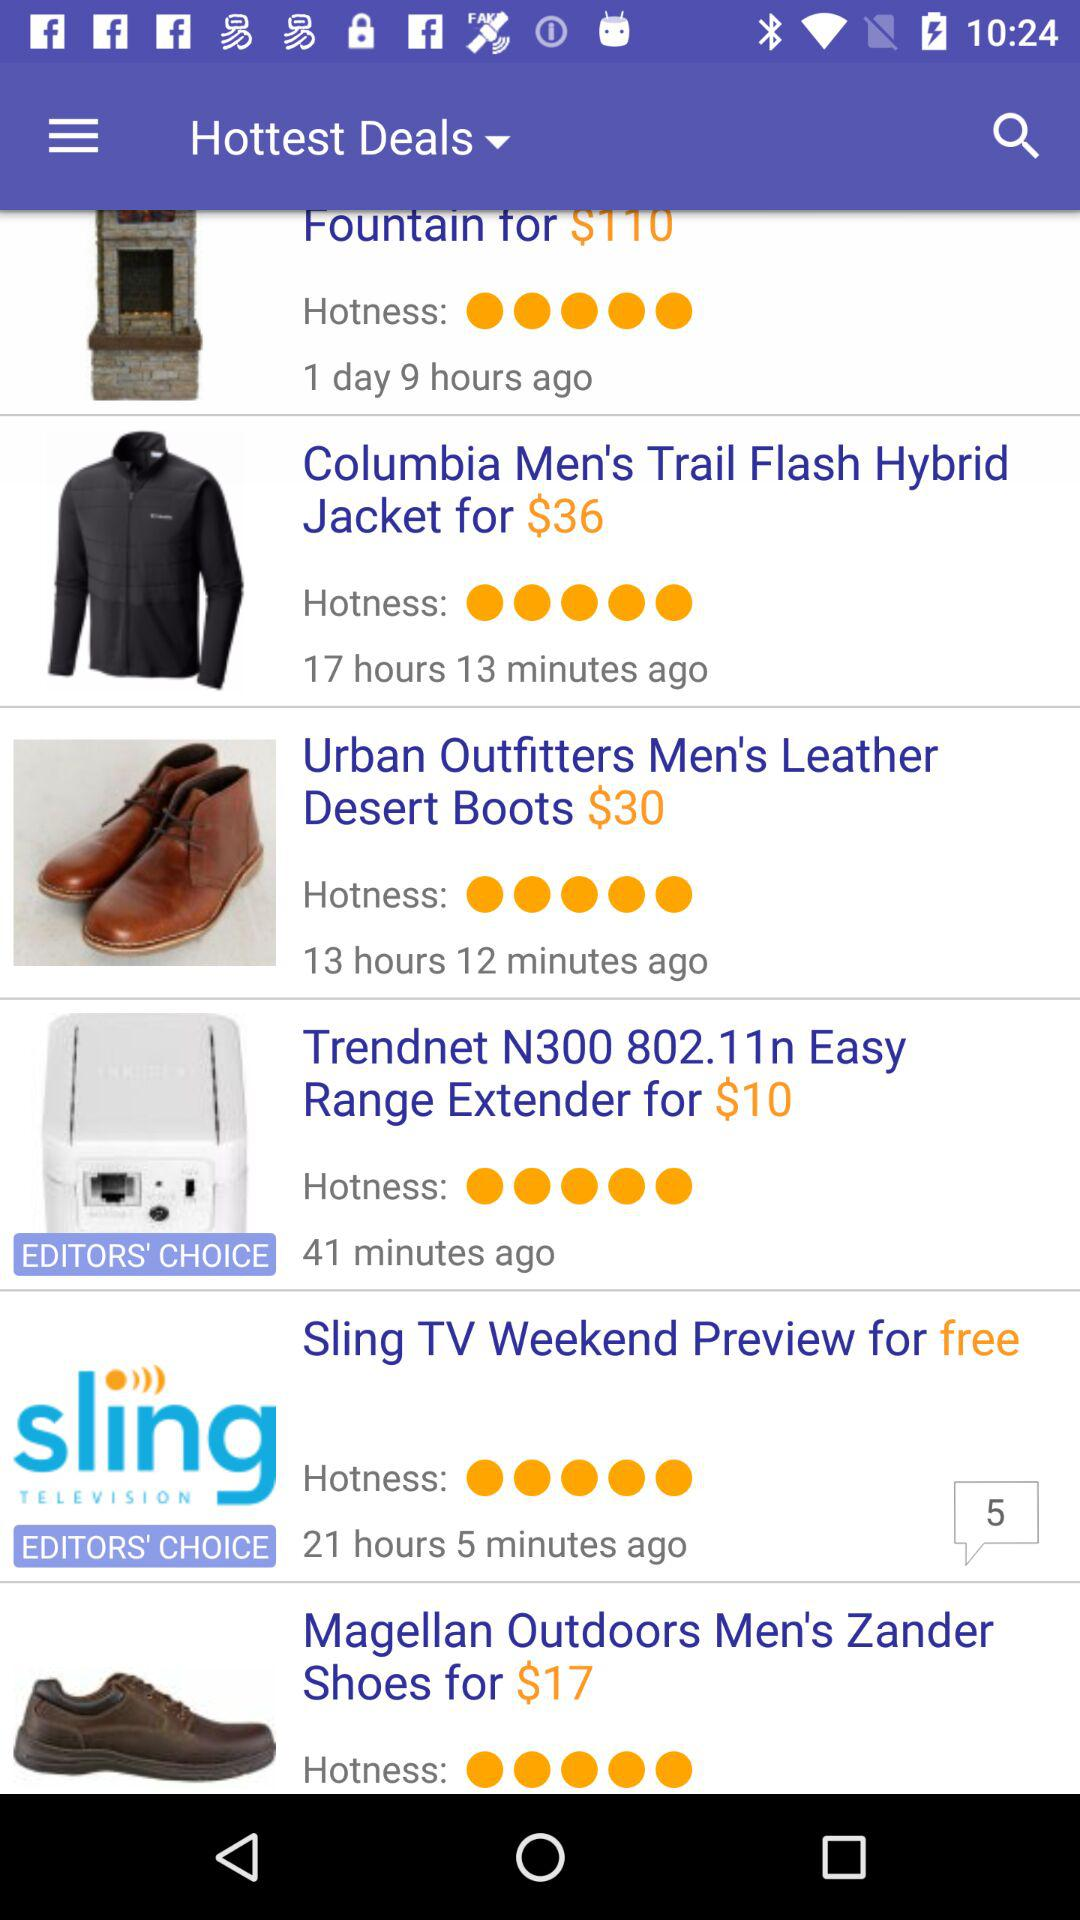How many more dollars is the item with the price $199.99 than the item with the price $110?
Answer the question using a single word or phrase. 89.99 